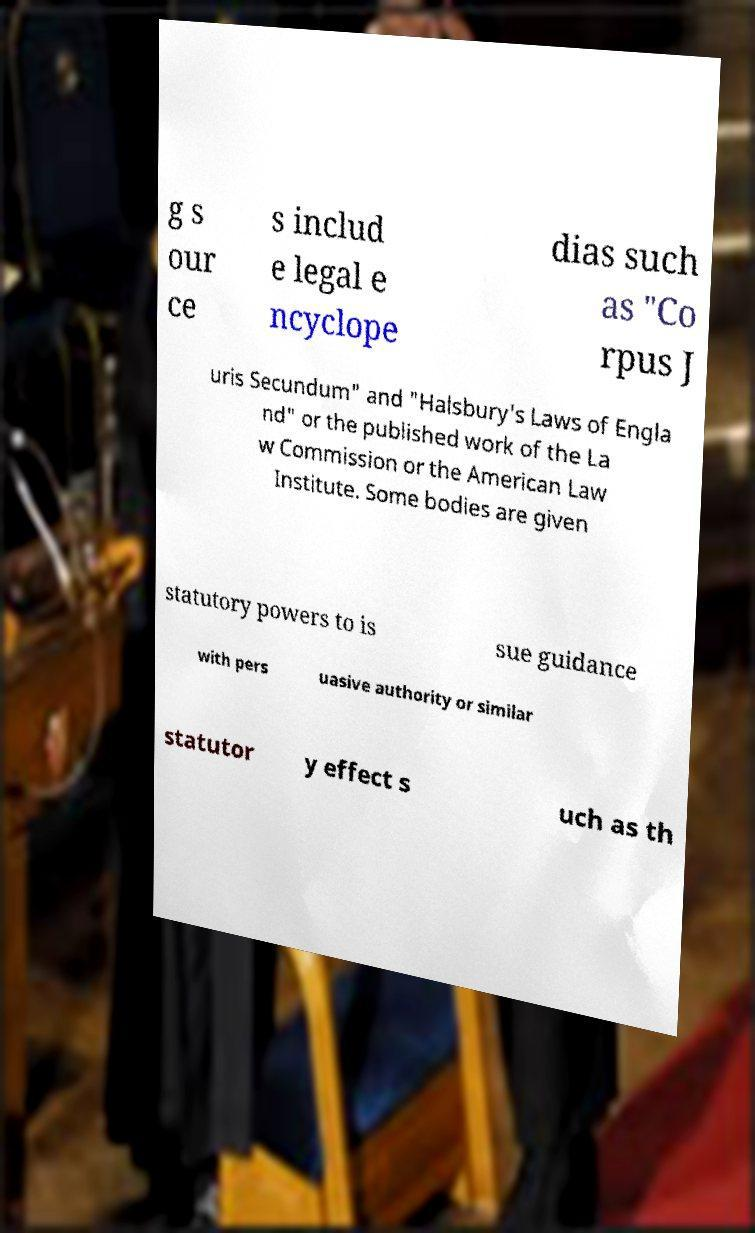I need the written content from this picture converted into text. Can you do that? g s our ce s includ e legal e ncyclope dias such as "Co rpus J uris Secundum" and "Halsbury's Laws of Engla nd" or the published work of the La w Commission or the American Law Institute. Some bodies are given statutory powers to is sue guidance with pers uasive authority or similar statutor y effect s uch as th 